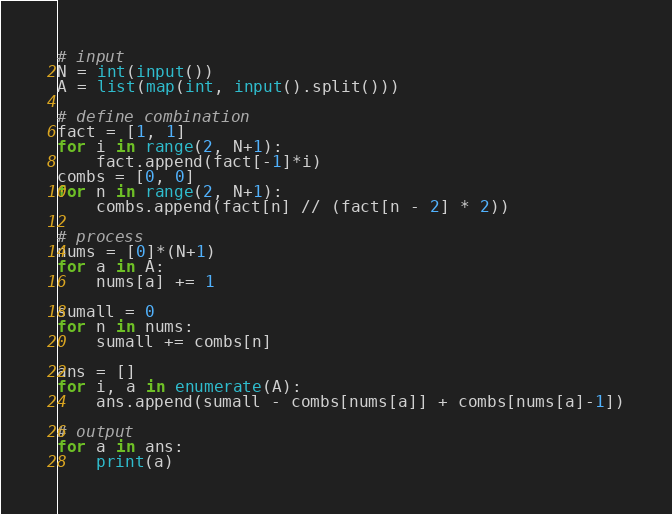Convert code to text. <code><loc_0><loc_0><loc_500><loc_500><_Python_># input
N = int(input())
A = list(map(int, input().split()))

# define combination
fact = [1, 1]
for i in range(2, N+1):
    fact.append(fact[-1]*i)
combs = [0, 0]
for n in range(2, N+1):
    combs.append(fact[n] // (fact[n - 2] * 2))

# process
nums = [0]*(N+1)
for a in A:
    nums[a] += 1

sumall = 0
for n in nums:
    sumall += combs[n]

ans = []
for i, a in enumerate(A):
    ans.append(sumall - combs[nums[a]] + combs[nums[a]-1])

# output
for a in ans:
    print(a)
</code> 